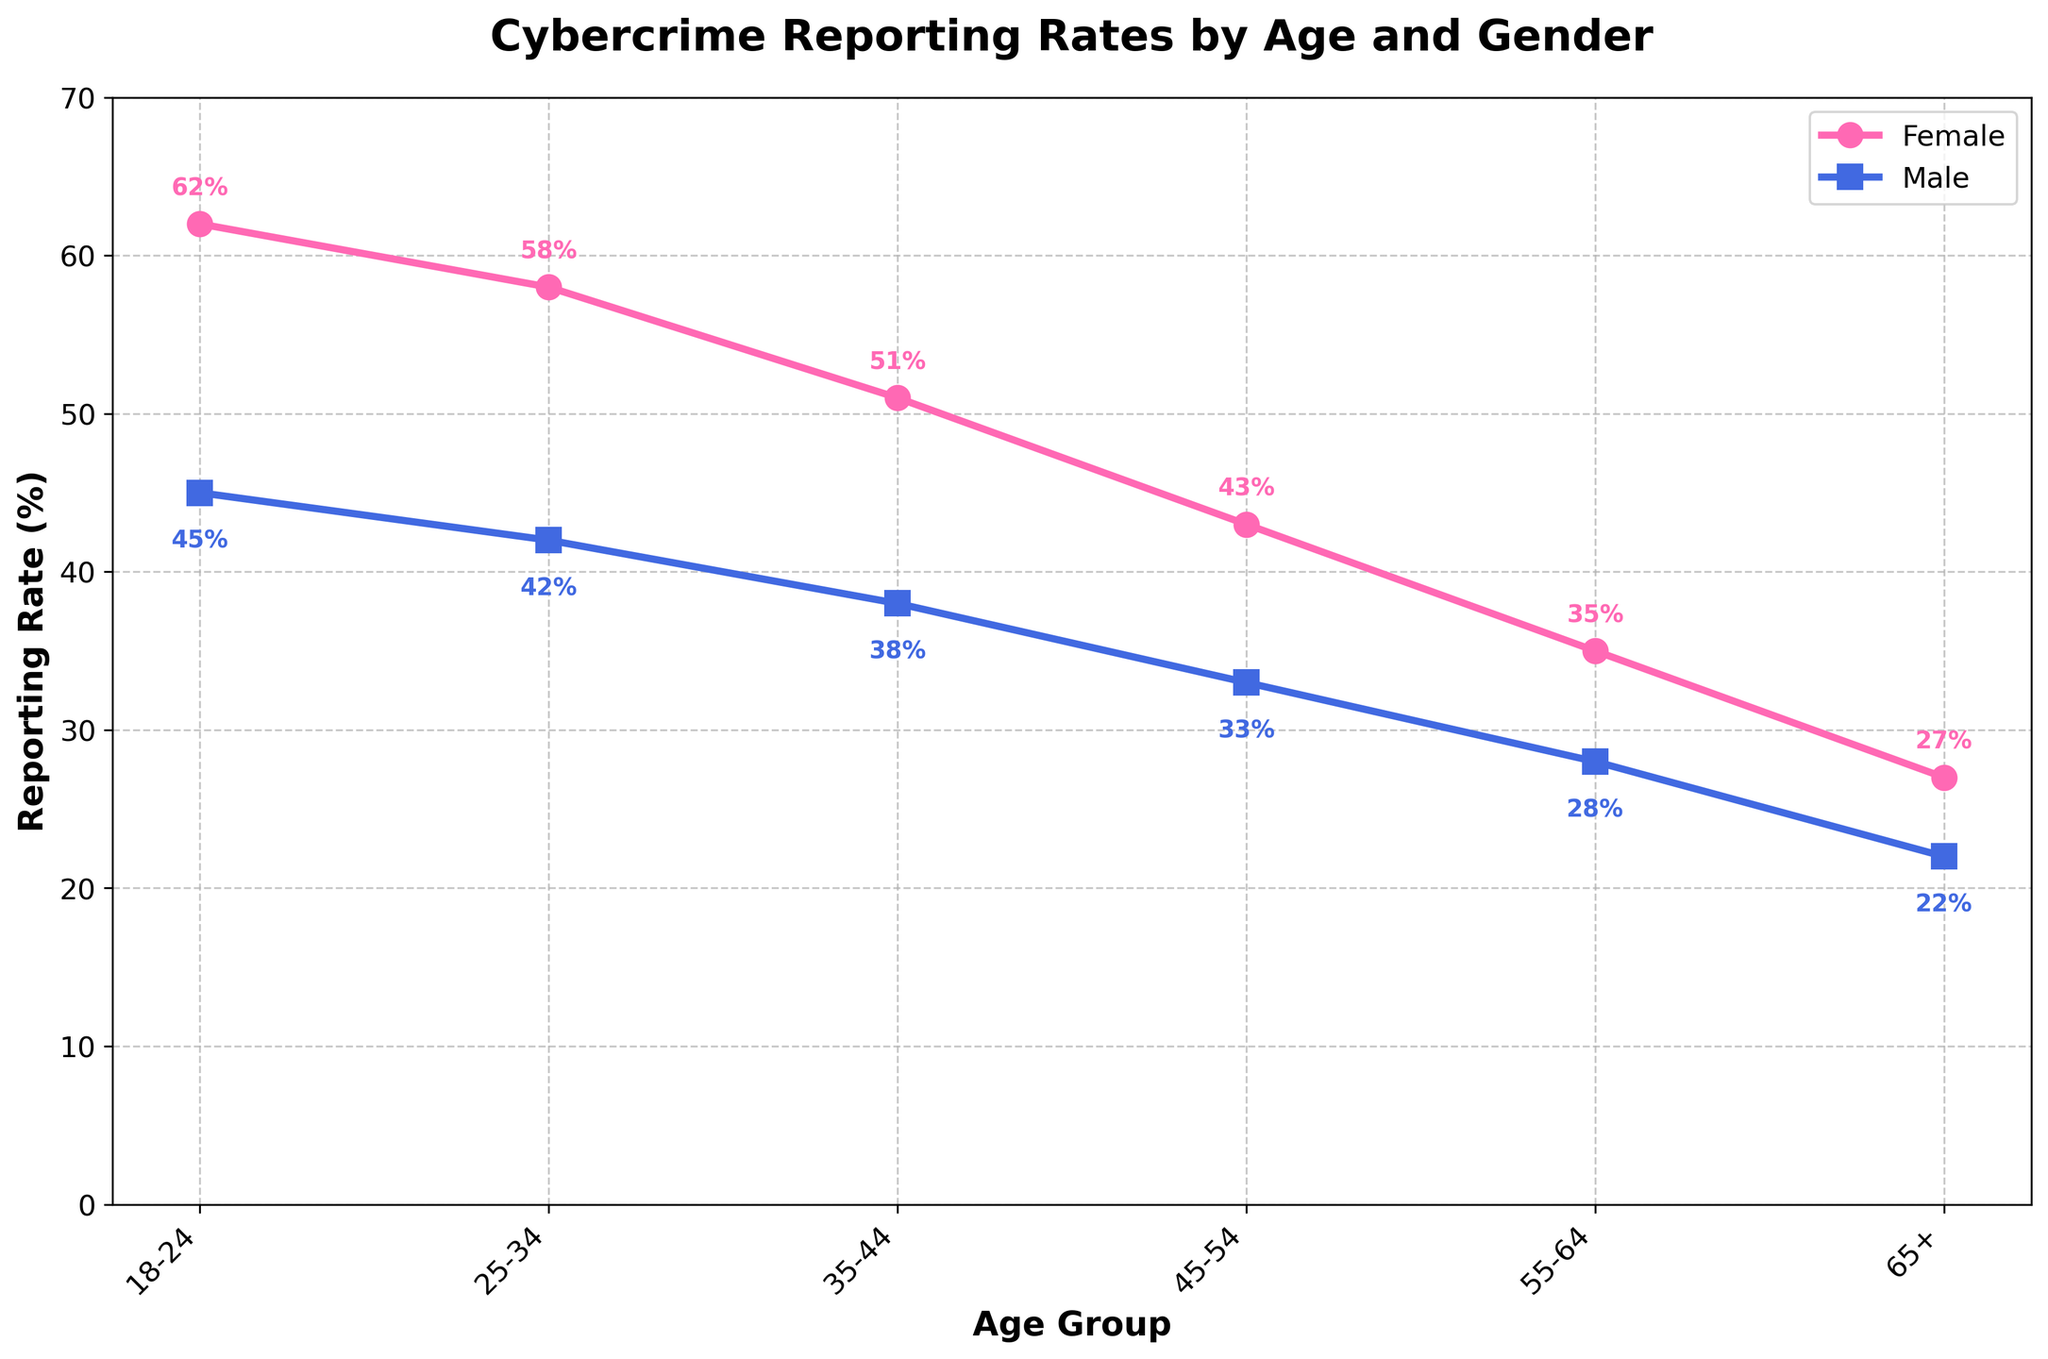Which age group has the highest female reporting rate? The age group 18-24 has the highest female reporting rate at 62%, as indicated by the highest point on the female line (pink).
Answer: 18-24 By how much does the reporting rate of males aged 25-34 differ from that of females in the same age group? The reporting rate of males aged 25-34 is 42%, and for females, it is 58%. Thus, the difference is 58% - 42% = 16%.
Answer: 16% What is the sum of the female reporting rates for the age groups 18-24 and 65+? The reporting rates for females in the age groups 18-24 and 65+ are 62% and 27%, respectively. Their sum is 62% + 27% = 89%.
Answer: 89% Between which age groups is there the largest decrease in the female reporting rate? The largest decrease in the female reporting rate occurs between age groups 18-24 and 25-34, with a drop from 62% to 58%, a difference of 4%.
Answer: 18-24 to 25-34 How many age groups have a female reporting rate above 40%? The age groups with a female reporting rate above 40% are 18-24, 25-34, and 35-44, making a total of 3 groups.
Answer: 3 What is the average male reporting rate across all age groups? The male reporting rates are 45%, 42%, 38%, 33%, 28%, and 22%. The sum is 208%, and there are 6 age groups, so the average is 208% / 6 ≈ 34.67%.
Answer: 34.67% Which age group has the smallest difference between male and female reporting rates? The age group 65+ has the smallest difference between male and female reporting rates, with a difference of 27% - 22% = 5%.
Answer: 65+ What is the trend in male reporting rates as the age group increases? The trend shows a decrease in male reporting rates as the age group increases, as seen from the progressively lower points on the male line (blue).
Answer: Decreasing Identify the age group where the gap between male and female reporting rates is the widest. What is this gap? The age group 18-24 has the widest gap between male and female reporting rates, with female at 62% and male at 45%, resulting in a gap of 62% - 45% = 17%.
Answer: 18-24, 17% 